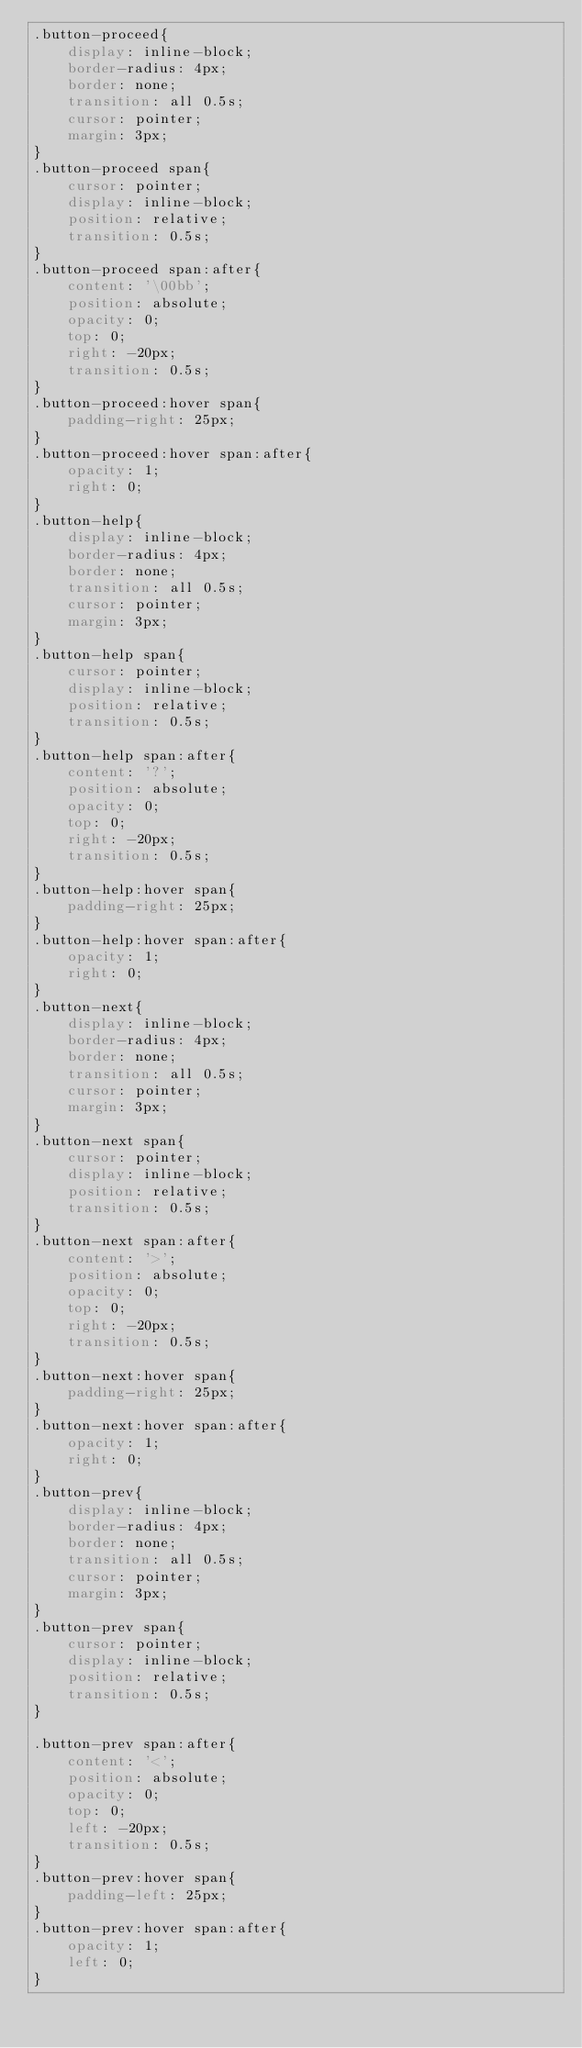Convert code to text. <code><loc_0><loc_0><loc_500><loc_500><_CSS_>.button-proceed{
    display: inline-block;
    border-radius: 4px;
    border: none;
    transition: all 0.5s;
    cursor: pointer;
    margin: 3px;
}
.button-proceed span{
    cursor: pointer;
    display: inline-block;
    position: relative;
    transition: 0.5s;
}
.button-proceed span:after{
    content: '\00bb';
    position: absolute;
    opacity: 0;
    top: 0;
    right: -20px;
    transition: 0.5s;
}
.button-proceed:hover span{
    padding-right: 25px;
}
.button-proceed:hover span:after{
    opacity: 1;
    right: 0;
}
.button-help{
    display: inline-block;
    border-radius: 4px;
    border: none;
    transition: all 0.5s;
    cursor: pointer;
    margin: 3px;
}
.button-help span{
    cursor: pointer;
    display: inline-block;
    position: relative;
    transition: 0.5s;
}
.button-help span:after{
    content: '?';
    position: absolute;
    opacity: 0;
    top: 0;
    right: -20px;
    transition: 0.5s;
}
.button-help:hover span{
    padding-right: 25px;
}
.button-help:hover span:after{
    opacity: 1;
    right: 0;
}
.button-next{
    display: inline-block;
    border-radius: 4px;
    border: none;
    transition: all 0.5s;
    cursor: pointer;
    margin: 3px;
}
.button-next span{
    cursor: pointer;
    display: inline-block;
    position: relative;
    transition: 0.5s;
}
.button-next span:after{
    content: '>';
    position: absolute;
    opacity: 0;
    top: 0;
    right: -20px;
    transition: 0.5s;
}
.button-next:hover span{
    padding-right: 25px;
}
.button-next:hover span:after{
    opacity: 1;
    right: 0;
}
.button-prev{
    display: inline-block;
    border-radius: 4px;
    border: none;
    transition: all 0.5s;
    cursor: pointer;
    margin: 3px;
}
.button-prev span{
    cursor: pointer;
    display: inline-block;
    position: relative;
    transition: 0.5s;
}

.button-prev span:after{
    content: '<';
    position: absolute;
    opacity: 0;
    top: 0;
    left: -20px;
    transition: 0.5s;
}
.button-prev:hover span{
    padding-left: 25px;
}
.button-prev:hover span:after{
    opacity: 1;
    left: 0;
}
</code> 